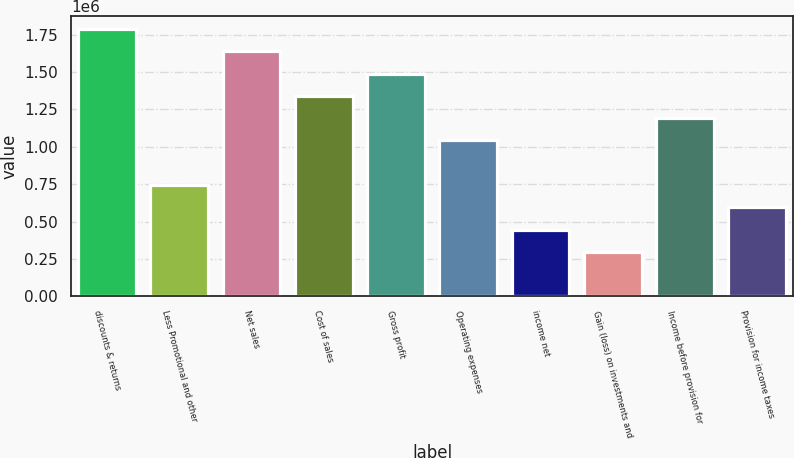Convert chart to OTSL. <chart><loc_0><loc_0><loc_500><loc_500><bar_chart><fcel>discounts & returns<fcel>Less Promotional and other<fcel>Net sales<fcel>Cost of sales<fcel>Gross profit<fcel>Operating expenses<fcel>income net<fcel>Gain (loss) on investments and<fcel>Income before provision for<fcel>Provision for income taxes<nl><fcel>1.78622e+06<fcel>744259<fcel>1.63737e+06<fcel>1.33966e+06<fcel>1.48852e+06<fcel>1.04196e+06<fcel>446556<fcel>297704<fcel>1.19081e+06<fcel>595407<nl></chart> 